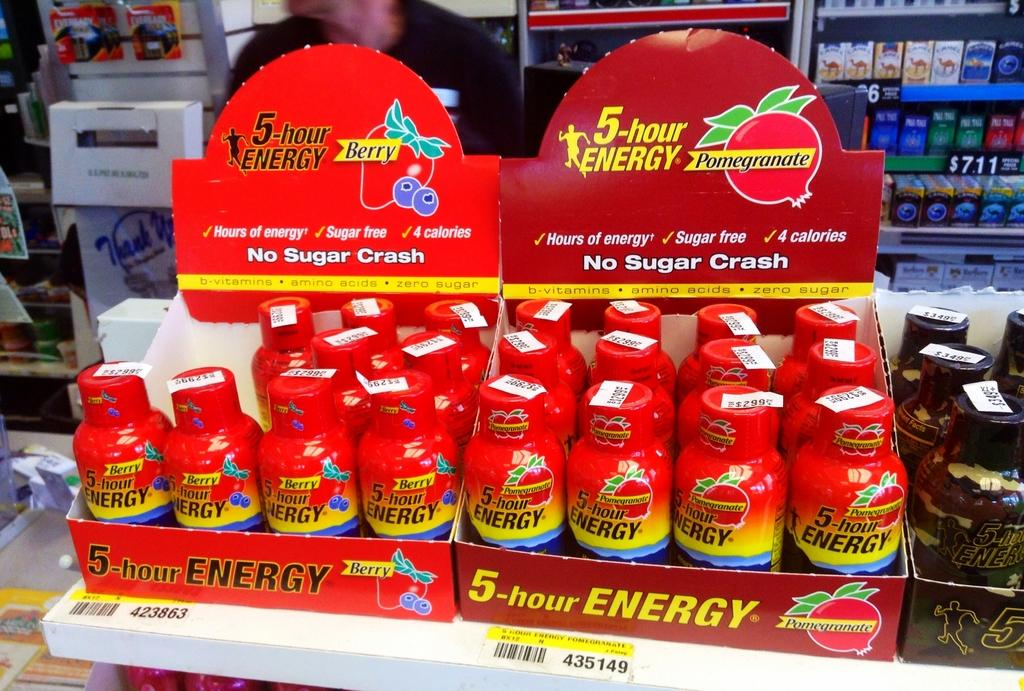<image>
Share a concise interpretation of the image provided. store display of 4-hour energy, one carton berry flavor, the other pomegranate 